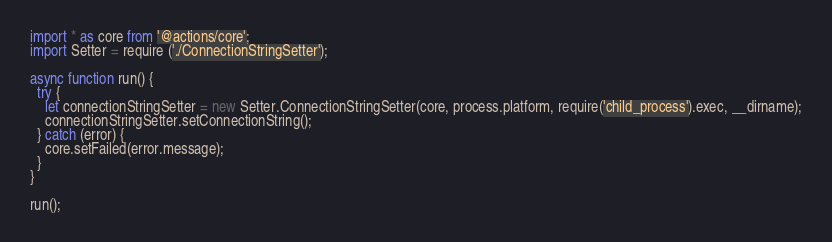<code> <loc_0><loc_0><loc_500><loc_500><_TypeScript_>import * as core from '@actions/core';
import Setter = require ('./ConnectionStringSetter');

async function run() {
  try {
    let connectionStringSetter = new Setter.ConnectionStringSetter(core, process.platform, require('child_process').exec, __dirname);
    connectionStringSetter.setConnectionString();
  } catch (error) {
    core.setFailed(error.message);
  }
}

run();
</code> 